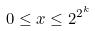<formula> <loc_0><loc_0><loc_500><loc_500>0 \leq x \leq 2 ^ { 2 ^ { k } }</formula> 